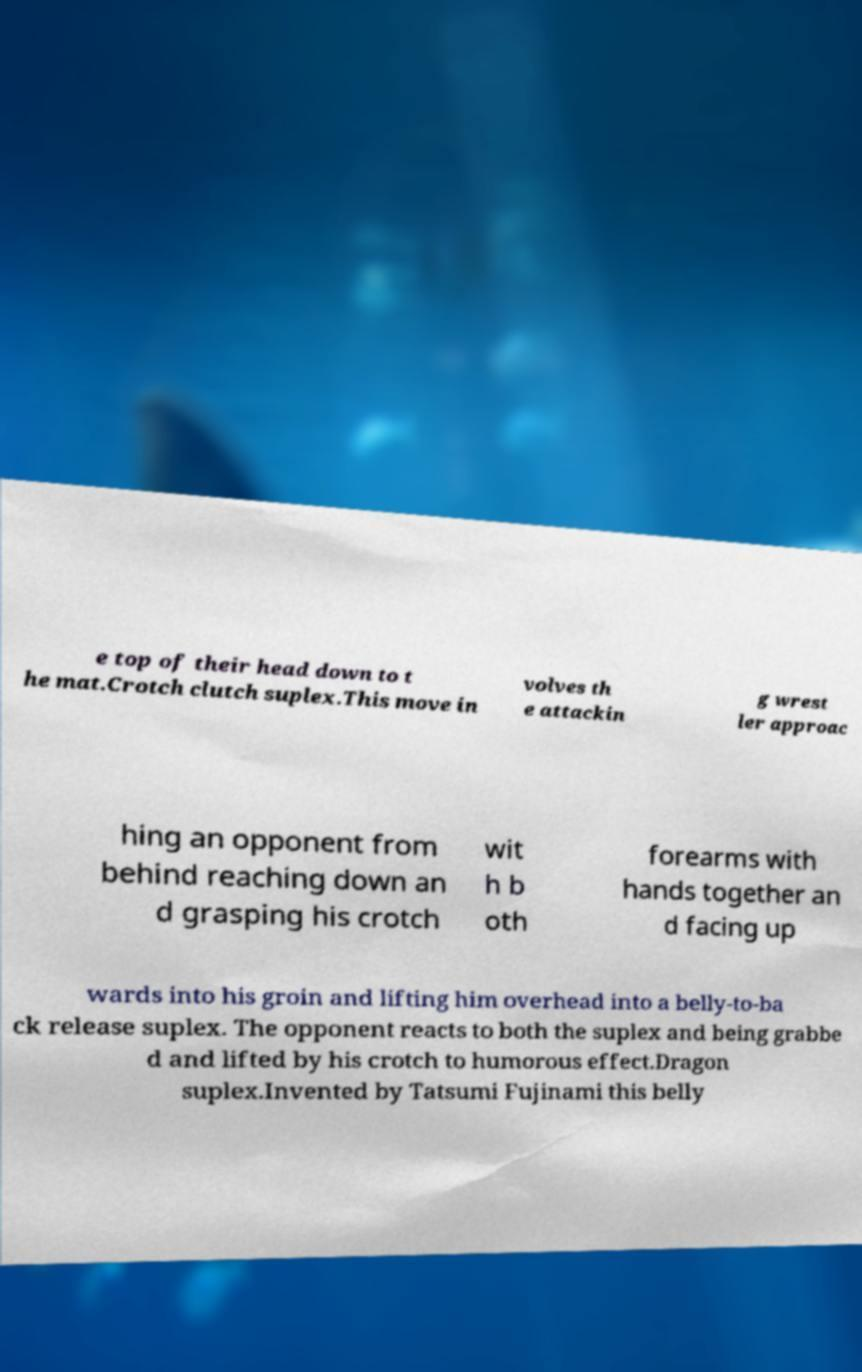Please read and relay the text visible in this image. What does it say? e top of their head down to t he mat.Crotch clutch suplex.This move in volves th e attackin g wrest ler approac hing an opponent from behind reaching down an d grasping his crotch wit h b oth forearms with hands together an d facing up wards into his groin and lifting him overhead into a belly-to-ba ck release suplex. The opponent reacts to both the suplex and being grabbe d and lifted by his crotch to humorous effect.Dragon suplex.Invented by Tatsumi Fujinami this belly 